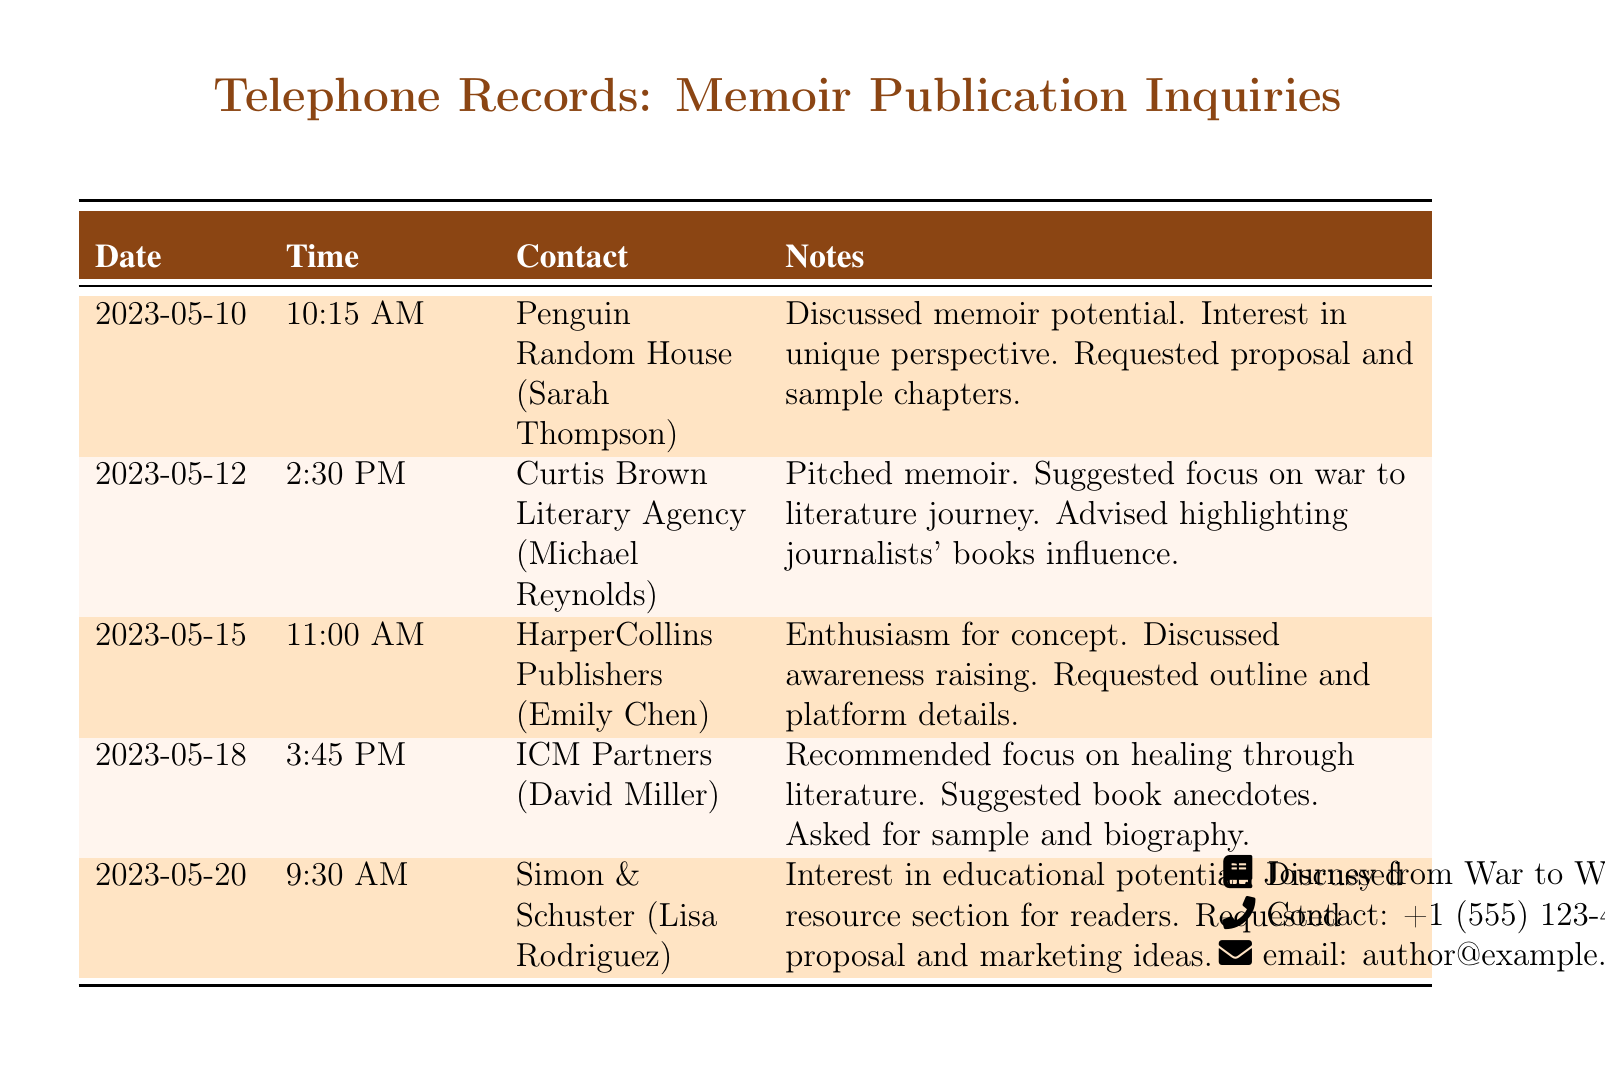What is the first contact listed in the document? The first contact is Penguin Random House, which is found in the first row of the table.
Answer: Penguin Random House What date did the call to HarperCollins Publishers occur? The date for the HarperCollins Publishers call is specifically indicated in the associated row.
Answer: 2023-05-15 Who is the agent from Curtis Brown Literary Agency? The agent’s name is mentioned alongside the agency in the relevant entry in the table.
Answer: Michael Reynolds What was discussed during the call with ICM Partners? The notes for the call with ICM Partners describe the specific discussion subjects.
Answer: Healing through literature How many calls were made to literary agents in total? The total number of calls is determined by counting the entries in the table.
Answer: 5 What did Simon & Schuster request? The specific request made by Simon & Schuster can be found in the notes section of their entry.
Answer: Proposal and marketing ideas Which publishing house expressed enthusiasm for the memoir concept? The enthusiasm for the concept can be directly found in the notes of one of the calls.
Answer: HarperCollins Publishers What is the contact email provided in the document? The email is given at the bottom of the document, representing the author's contact details.
Answer: author@example.com What was one suggested focus during the call with Curtis Brown Literary Agency? The suggestions can be found in the notes for that specific call in the records.
Answer: War to literature journey 